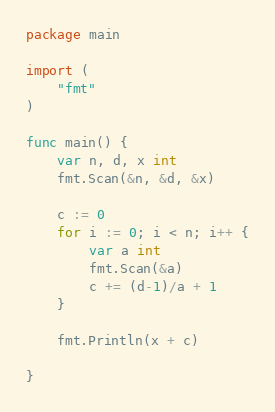Convert code to text. <code><loc_0><loc_0><loc_500><loc_500><_Go_>package main

import (
	"fmt"
)

func main() {
	var n, d, x int
	fmt.Scan(&n, &d, &x)

	c := 0
	for i := 0; i < n; i++ {
		var a int
		fmt.Scan(&a)
		c += (d-1)/a + 1
	}

	fmt.Println(x + c)

}
</code> 